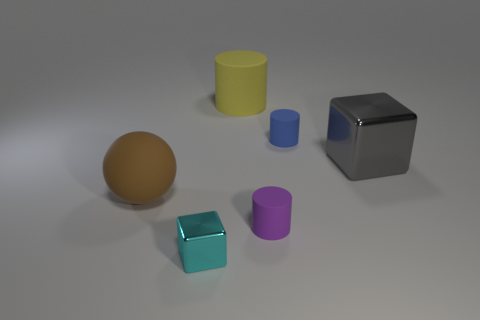How many objects are either gray blocks or objects left of the blue cylinder?
Make the answer very short. 5. Is the number of large brown objects less than the number of big brown metallic cylinders?
Provide a short and direct response. No. There is a small rubber cylinder that is behind the metal thing behind the ball; what color is it?
Provide a succinct answer. Blue. What material is the tiny cyan thing that is the same shape as the gray thing?
Offer a terse response. Metal. What number of metal things are either big brown cylinders or big cylinders?
Offer a terse response. 0. Are the big thing that is in front of the large gray thing and the tiny cylinder behind the large gray block made of the same material?
Your answer should be very brief. Yes. Is there a large purple metallic block?
Offer a terse response. No. Is the shape of the large rubber object in front of the large yellow thing the same as the big gray thing behind the cyan thing?
Provide a succinct answer. No. Is there a green sphere made of the same material as the yellow cylinder?
Provide a short and direct response. No. Are the object on the left side of the tiny cyan shiny thing and the gray block made of the same material?
Ensure brevity in your answer.  No. 